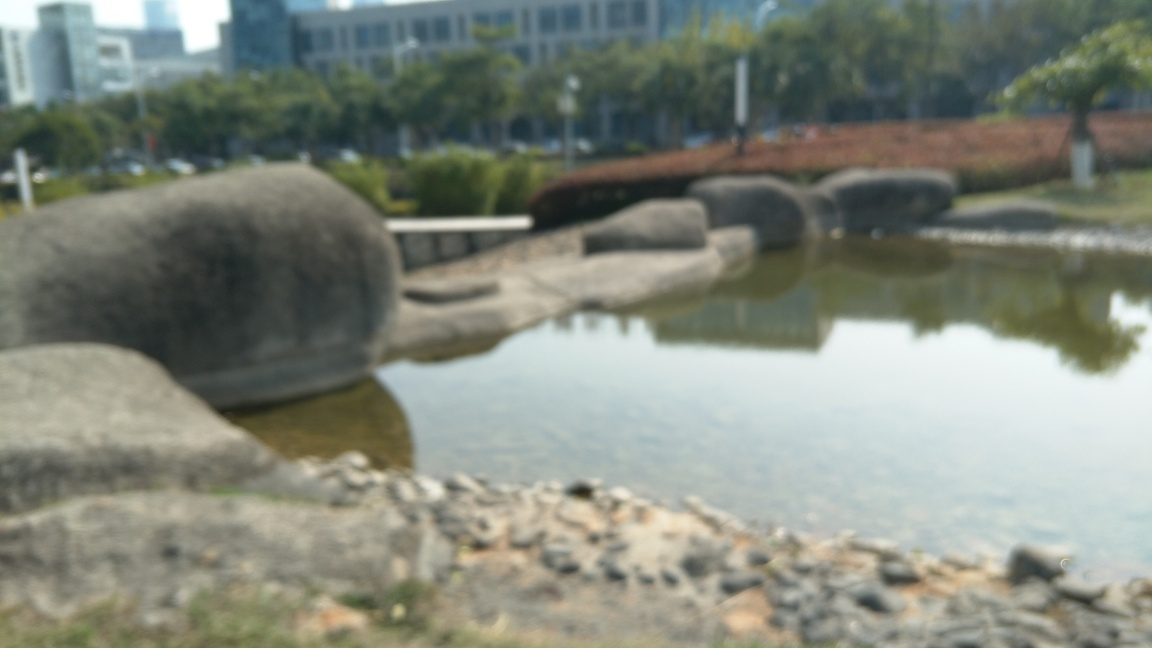What could be the significance or purpose of the large objects in the image? Although the details are obscured, the large objects in the image give the impression of being sculptural installations, possibly designed to harmonize with the natural landscape. Given their prominent placement by the water, they could serve as a focal point for visitors, encouraging contemplation or simply enhancing the aesthetic appeal of the area. The forms might be abstract representations, allowing for diverse interpretations of their significance, ranging from natural forms to artistic expressions. 